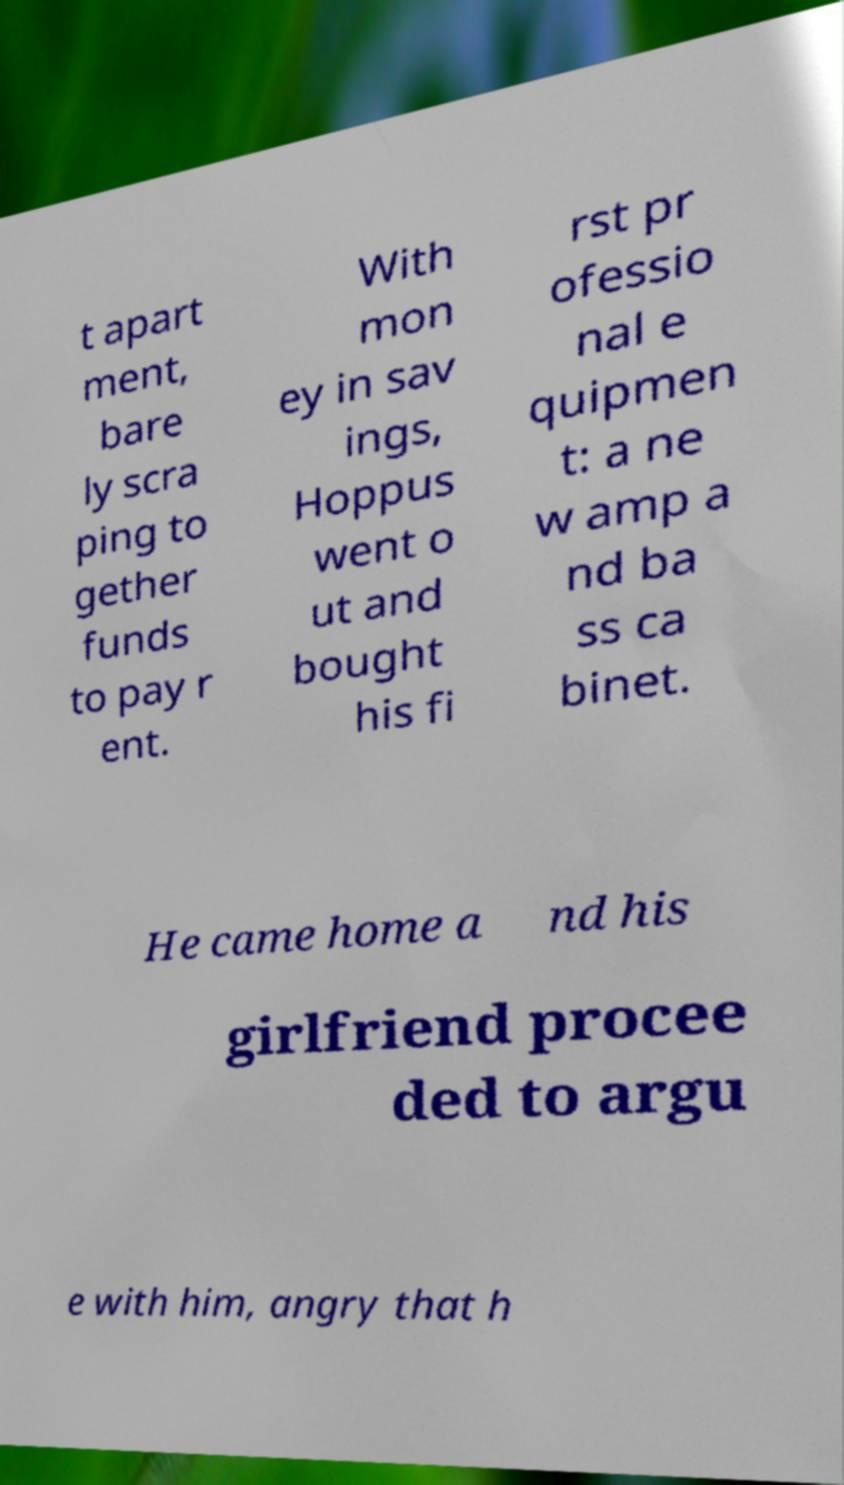Please read and relay the text visible in this image. What does it say? t apart ment, bare ly scra ping to gether funds to pay r ent. With mon ey in sav ings, Hoppus went o ut and bought his fi rst pr ofessio nal e quipmen t: a ne w amp a nd ba ss ca binet. He came home a nd his girlfriend procee ded to argu e with him, angry that h 